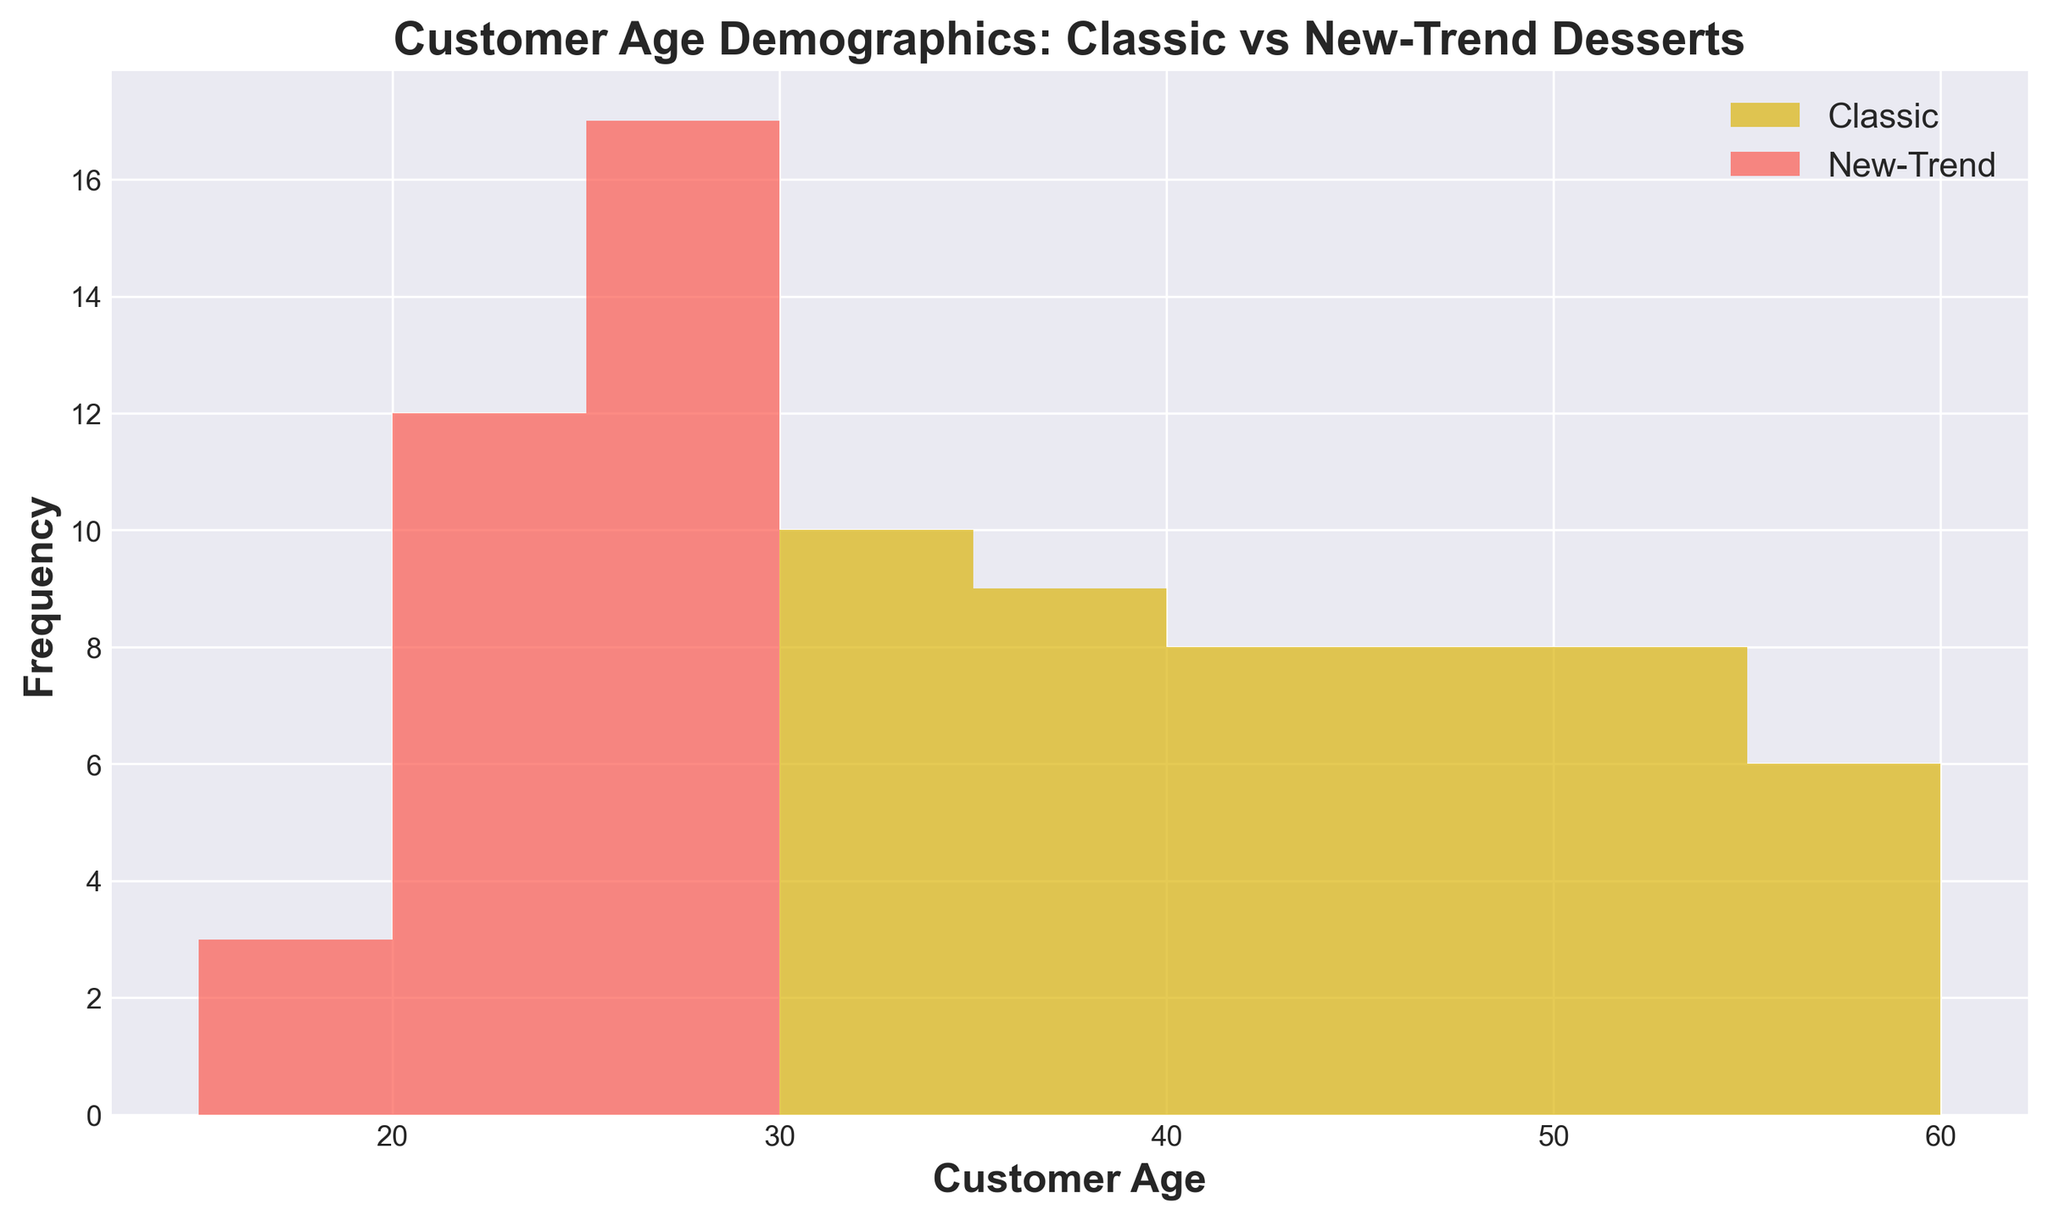What's the most frequent age range for customers preferring Classic desserts? The most frequent age range is observed by looking at the tallest bar in the "Classic" histogram, which is between 35 and 40.
Answer: 35-40 Between which two age ranges is the gap in new-trend dessert preference the largest? The histogram shows the largest gap between the tallest and the next tallest bars in "New-Trend". This appears between the age ranges 20-25 and 25-30.
Answer: 20-25 and 25-30 How do the frequency counts compare for ages 45-50 between Classic and New-Trend desserts? For the age range 45-50, "Classic" has a taller bar compared to "New-Trend", indicating higher frequency for Classic desserts.
Answer: Classic What is the average age of customers preferring new-trend desserts in the 20-30 age range? Sum the ages 20, 21, 22, 22, 23, 24, 24, 25, 25, 26, 26, 26, 27, 27, 27, 28, 28, 29, 29, 29, 29, 29 within 20-30 and divide by the number of values. (20+21+22+22+23+24+24+25+25+26+26+26+27+27+27+28+28+29+29+29+29+29) / 22 = 25.18
Answer: 25.18 Does any age range show equal preferences for Classic and New-Trend desserts? No bars from both histograms reach the same height at any age range.
Answer: No What's the frequency for Classic desserts among 30-35 year-olds? Observe the height of the bars in the "Classic" histogram for the age ranges 30-35. Summing up the values for 30, 31, 32, 33, 34, 35, we get a total of 7 counts.
Answer: 7 Which group has more diverse age ranges, Classic or New-Trend? The group with more consistently spread-out bars over different age ranges shows more diversity. Classic tends to span a wider age range from younger to older ages while New-Trend is more concentrated in younger age ranges.
Answer: Classic For the age range 50-55, which preference dominates, and by how much? Compare the bar heights in the specified age range. "Classic" dominates since the "New-Trend" has a frequency of 0 there. The difference is the entire frequency count for Classic, which is 4.
Answer: Classic, by 4 